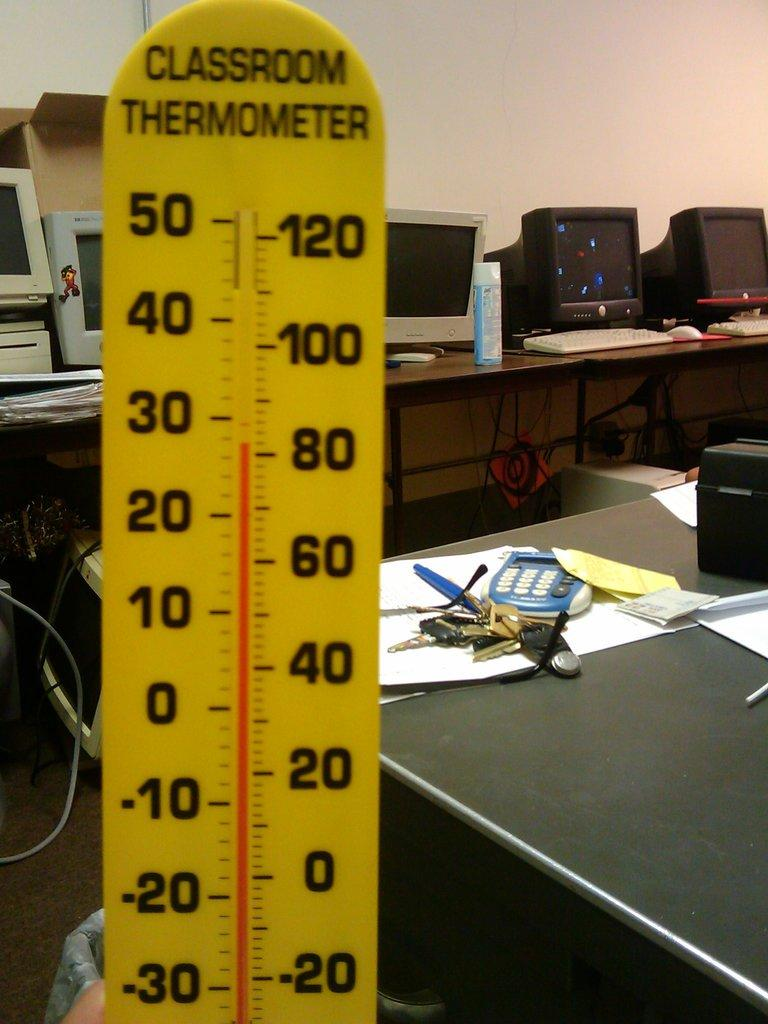<image>
Share a concise interpretation of the image provided. A classroom thermometer showing 81 degrees Fahrenheit with several old computer monitors lining the wall. 